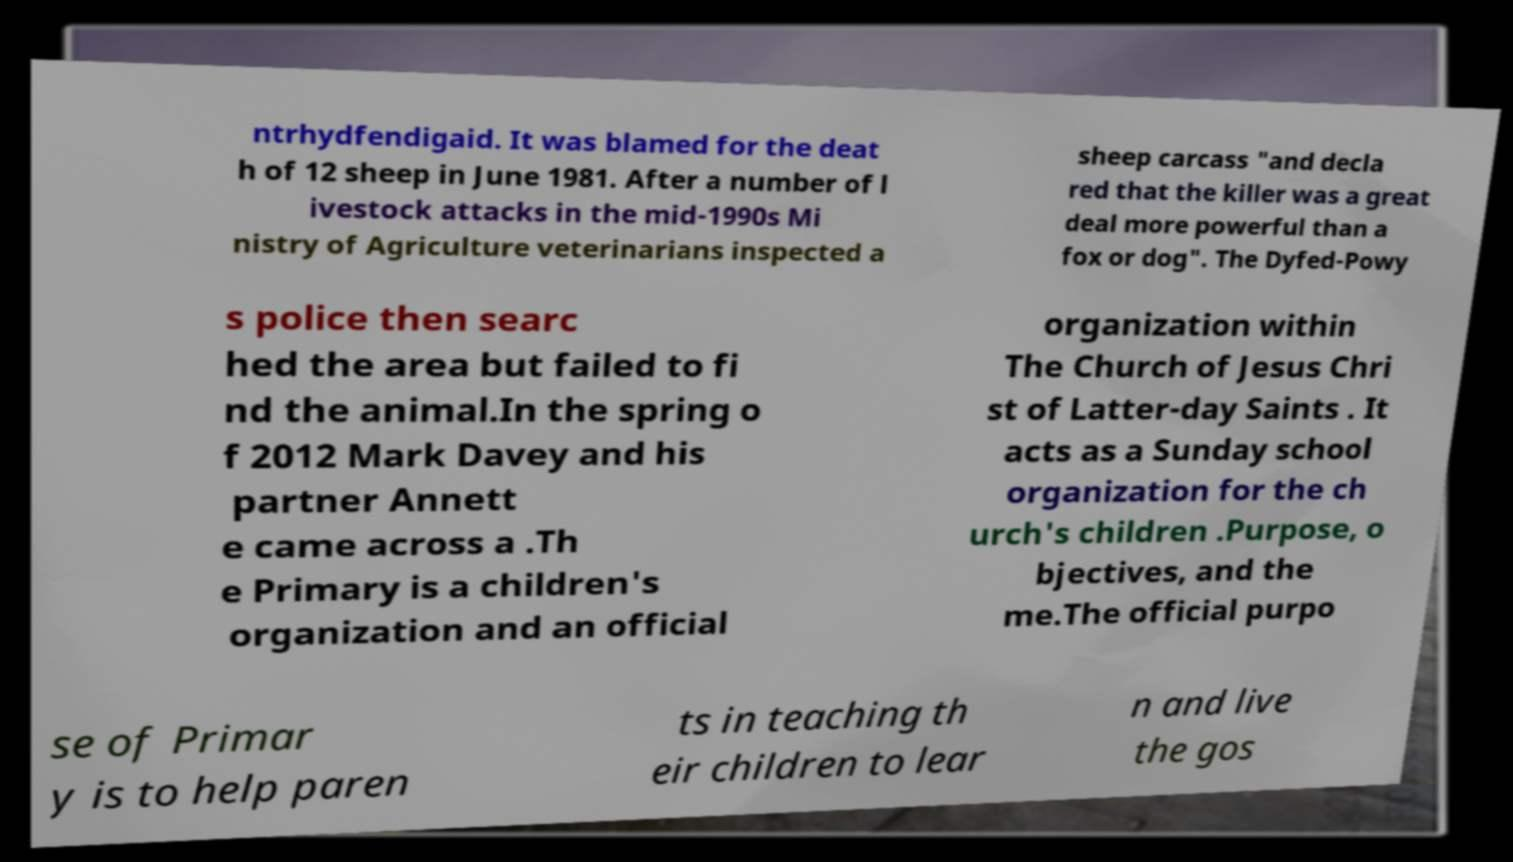Please read and relay the text visible in this image. What does it say? ntrhydfendigaid. It was blamed for the deat h of 12 sheep in June 1981. After a number of l ivestock attacks in the mid-1990s Mi nistry of Agriculture veterinarians inspected a sheep carcass "and decla red that the killer was a great deal more powerful than a fox or dog". The Dyfed-Powy s police then searc hed the area but failed to fi nd the animal.In the spring o f 2012 Mark Davey and his partner Annett e came across a .Th e Primary is a children's organization and an official organization within The Church of Jesus Chri st of Latter-day Saints . It acts as a Sunday school organization for the ch urch's children .Purpose, o bjectives, and the me.The official purpo se of Primar y is to help paren ts in teaching th eir children to lear n and live the gos 